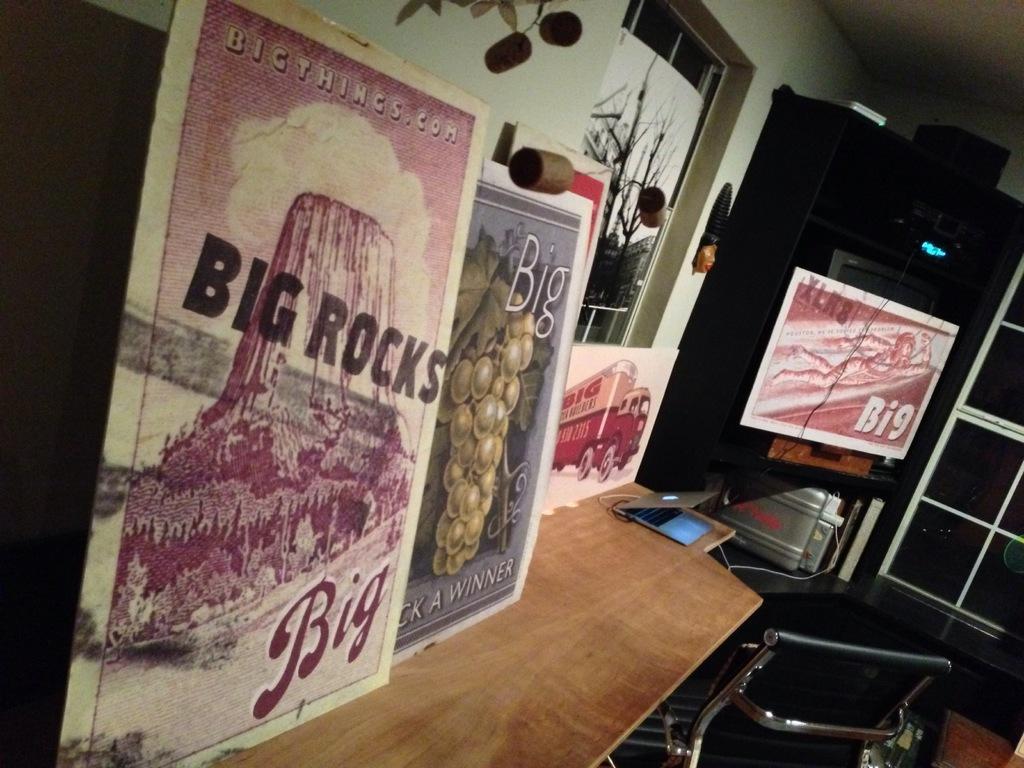How would you summarize this image in a sentence or two? In this image we can see boards and a laptop on a wooden board, chair on the floor. We can see a board, objects and TV on the racks. There are pictures on the wall, board at the window and objects. 